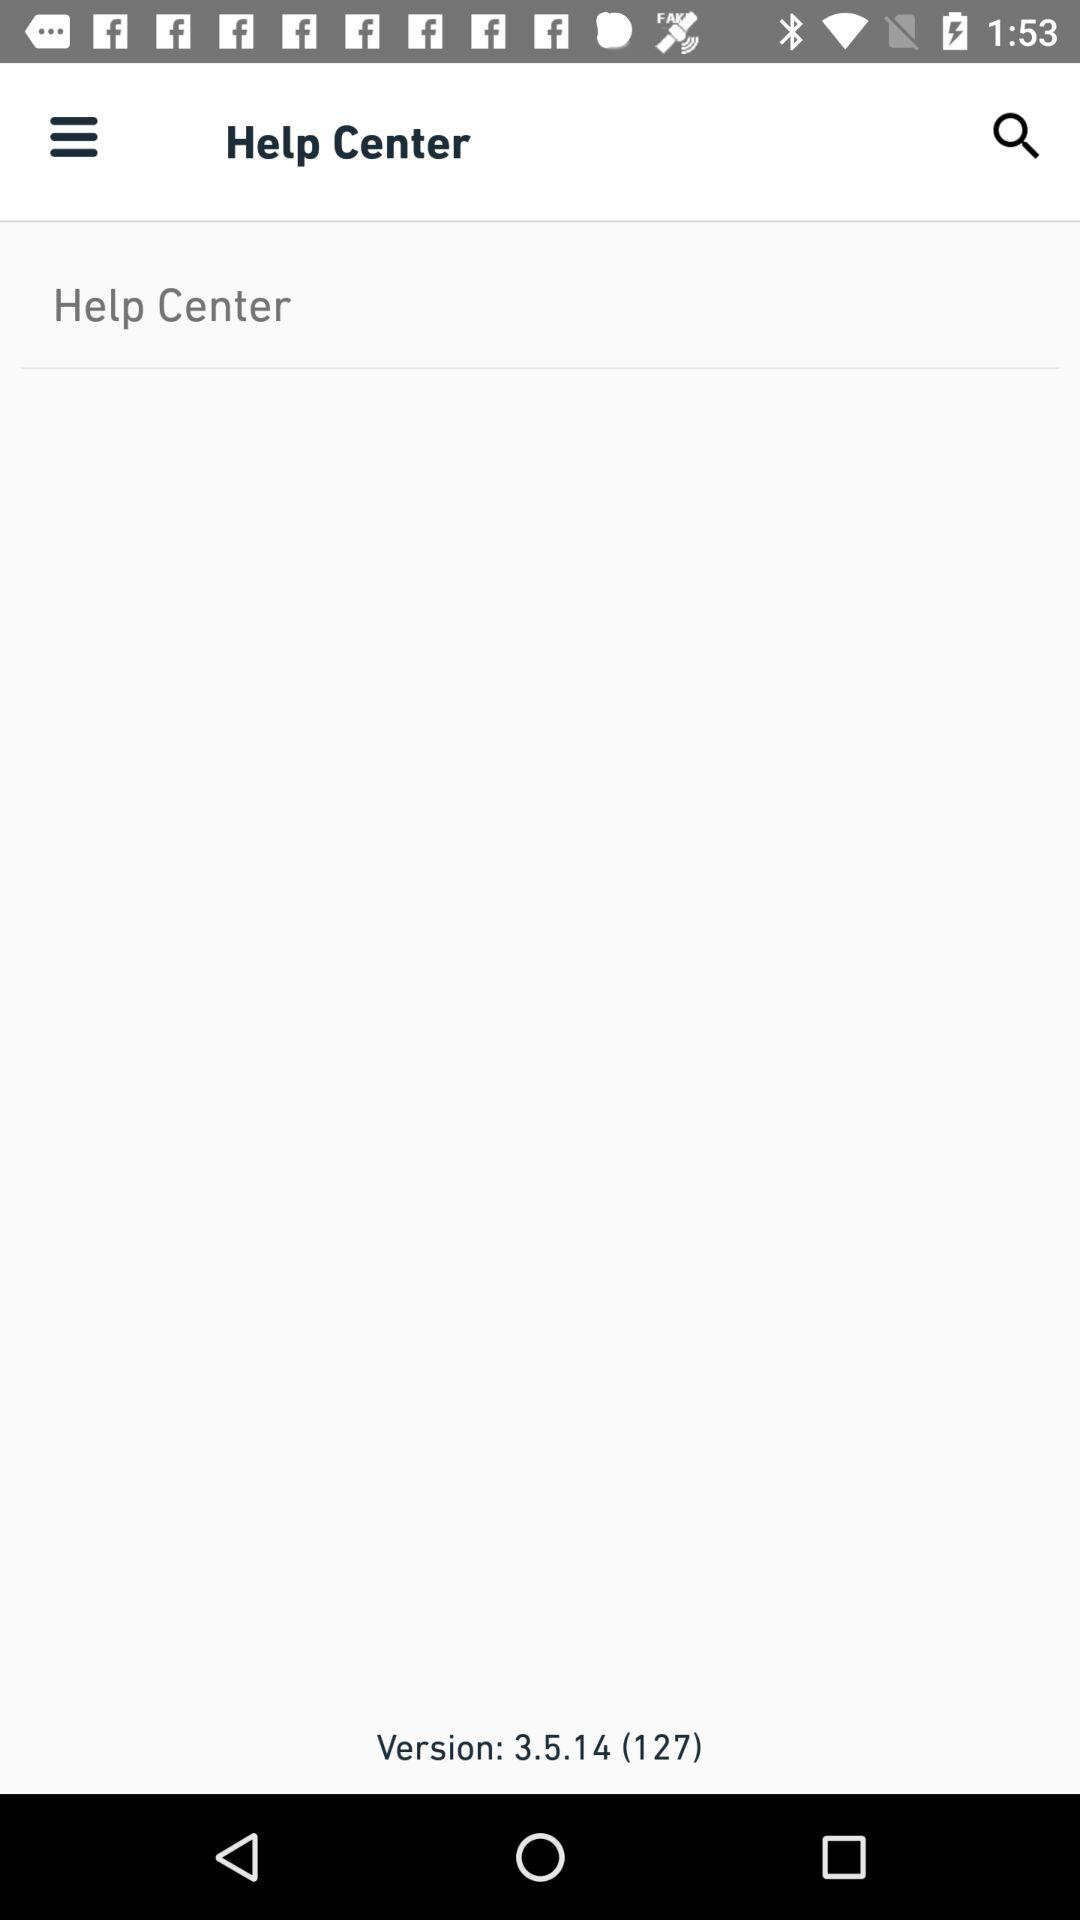What is the name of application?
When the provided information is insufficient, respond with <no answer>. <no answer> 